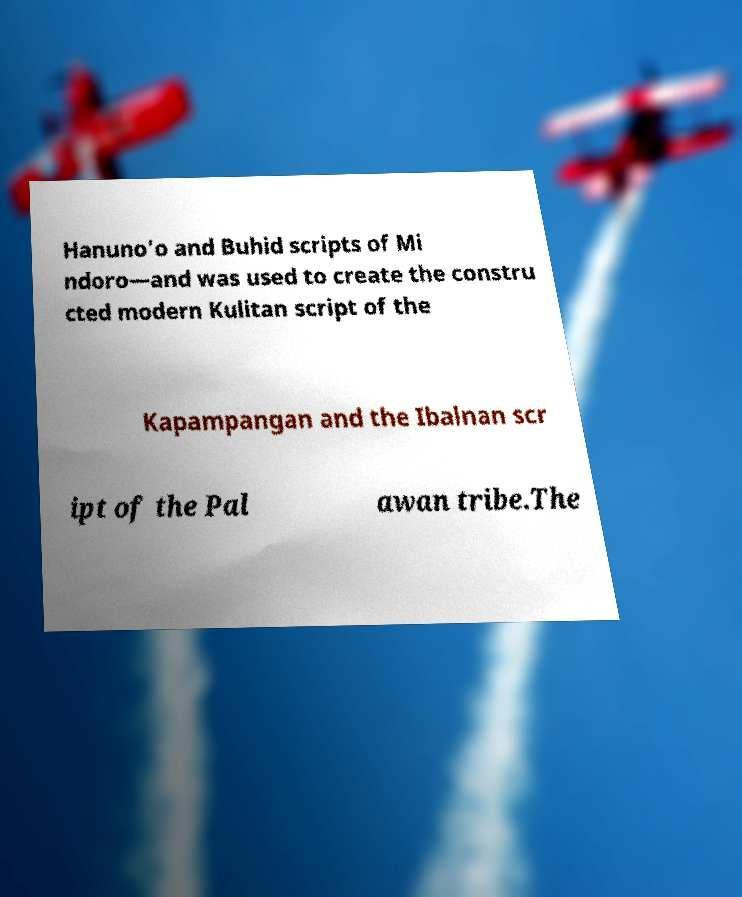There's text embedded in this image that I need extracted. Can you transcribe it verbatim? Hanuno'o and Buhid scripts of Mi ndoro—and was used to create the constru cted modern Kulitan script of the Kapampangan and the Ibalnan scr ipt of the Pal awan tribe.The 